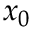<formula> <loc_0><loc_0><loc_500><loc_500>x _ { 0 }</formula> 